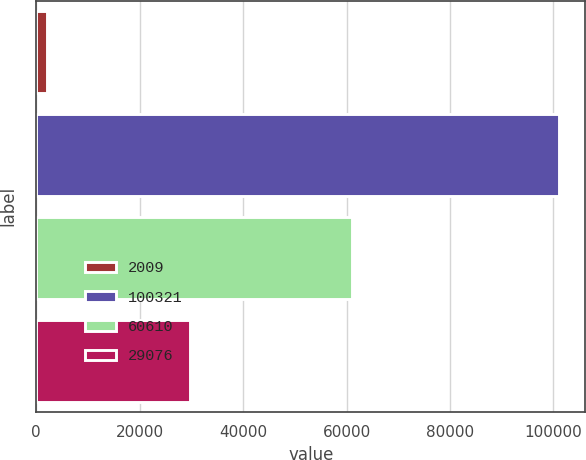Convert chart. <chart><loc_0><loc_0><loc_500><loc_500><bar_chart><fcel>2009<fcel>100321<fcel>60610<fcel>29076<nl><fcel>2009<fcel>101096<fcel>61121<fcel>29810<nl></chart> 